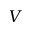<formula> <loc_0><loc_0><loc_500><loc_500>V</formula> 